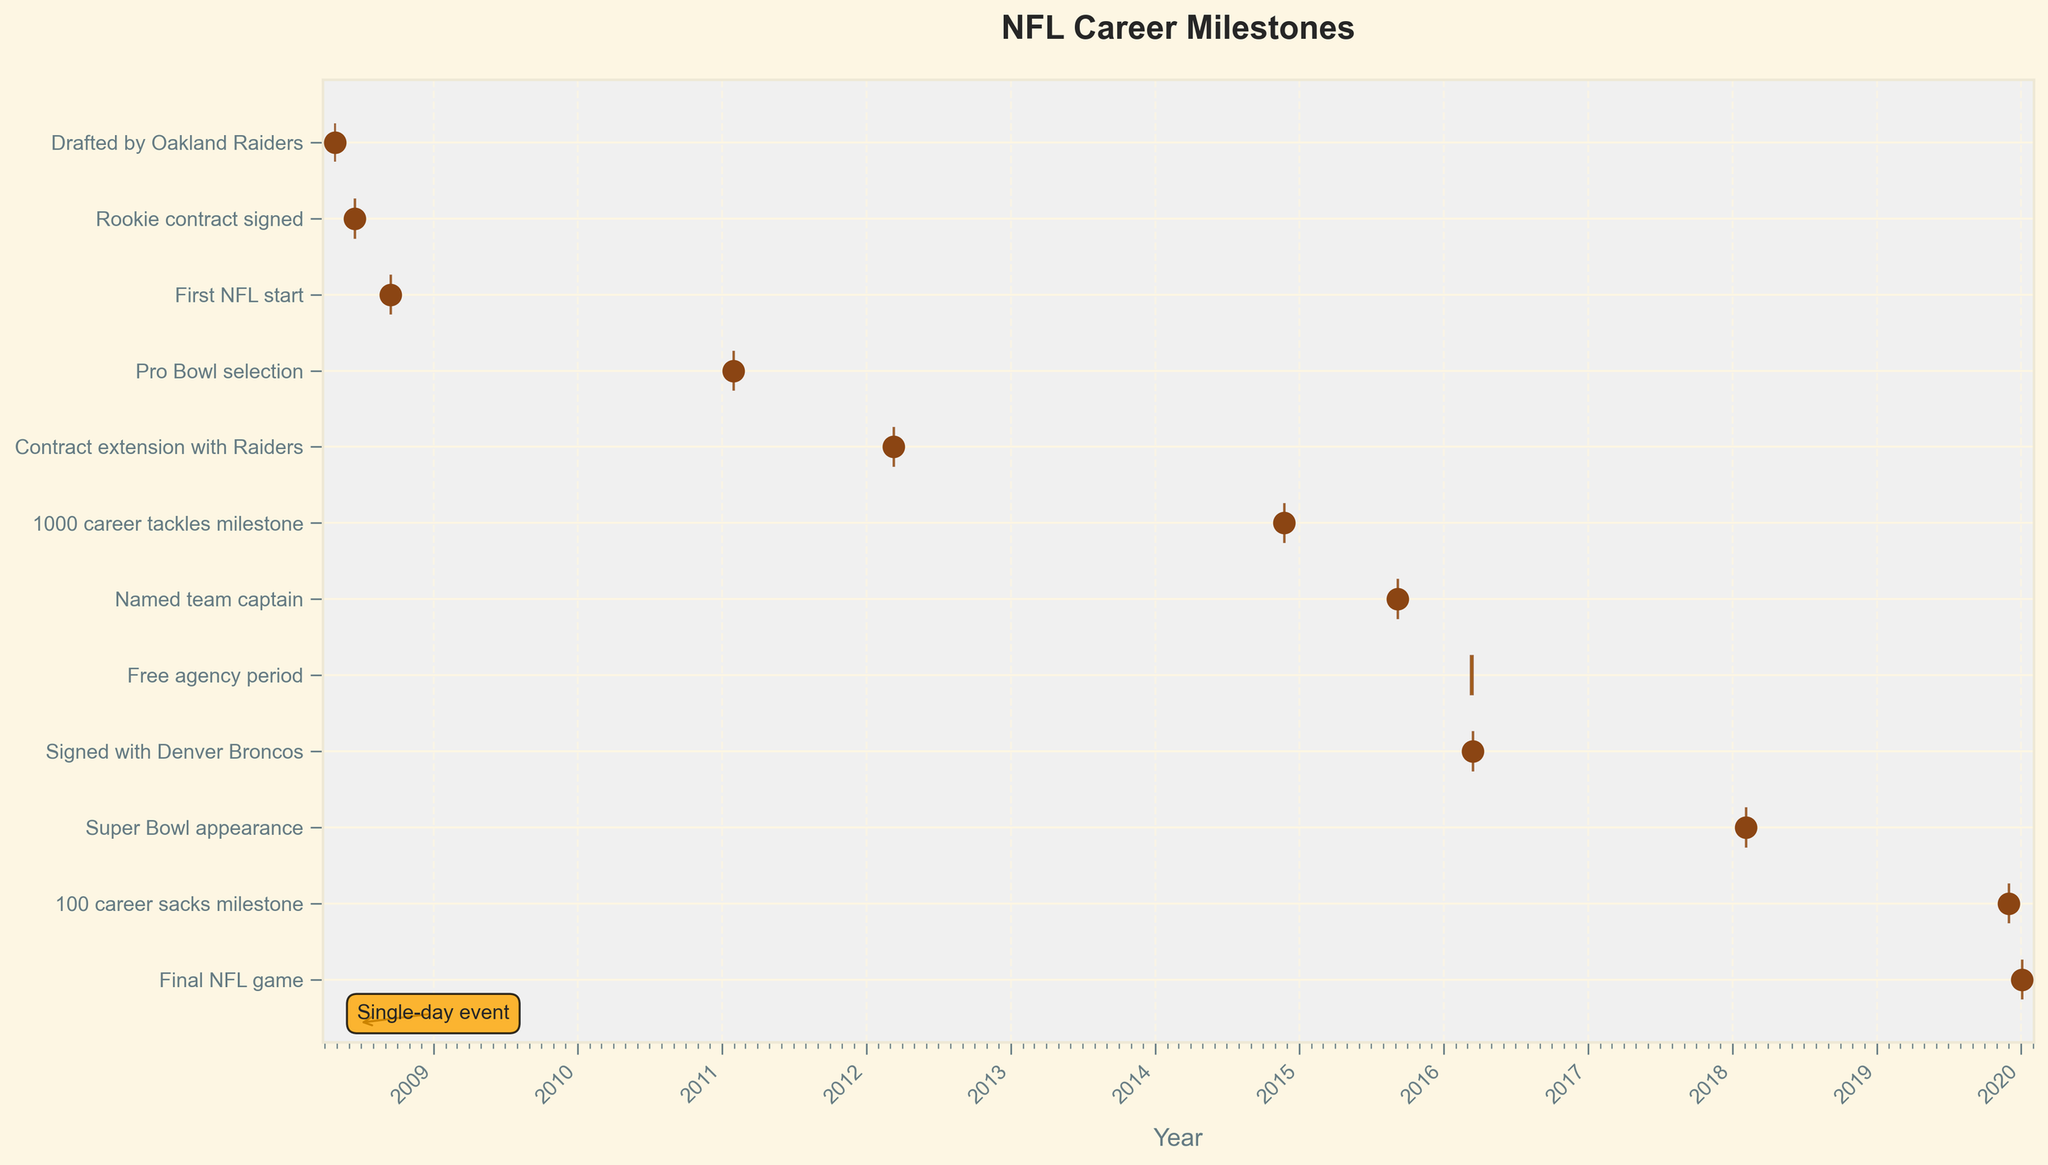What event marks the beginning of the player's professional NFL career? The event marking the beginning of the player's professional NFL career is "Drafted by Oakland Raiders". This can be seen at the earliest date on the Gantt Chart, which is April 26, 2008.
Answer: Drafted by Oakland Raiders How many days does the free agency period last? The "Free agency period" lasts from March 9, 2016, to March 14, 2016. By calculating the duration, (March 14 - March 9) including both start and end dates, we get a total of 6 days.
Answer: 6 days Which events are represented as single-day events with markers on the Gantt Chart? The events represented as single-day events with markers are: "Drafted by Oakland Raiders," "Rookie contract signed," "First NFL start," "Pro Bowl selection," "Contract extension with Raiders," "1000 career tackles milestone," "Named team captain," "Signed with Denver Broncos," "Super Bowl appearance," "100 career sacks milestone," and "Final NFL game." These all occur on a single day as shown with markers.
Answer: 11 events When did the player sign with the Denver Broncos? The player signed with the Denver Broncos on March 15, 2016, as seen on the Gantt Chart under the task "Signed with Denver Broncos."
Answer: March 15, 2016 Which event came first: Pro Bowl selection or the Contract extension with Raiders? The Pro Bowl selection occurred on January 30, 2011, which can be observed before the Contract extension with the Raiders that happened on March 10, 2012, in the sequential order on the Gantt Chart.
Answer: Pro Bowl selection How long after being drafted did the player reach 1000 career tackles milestone? The player was drafted on April 26, 2008, and reached the 1000 career tackles milestone on November 23, 2014. To find the duration between these dates: 2014-04-26 to 2014-11-23 gives 6 years and roughly 7 months.
Answer: 6 years and 7 months Compare the time intervals between the Contract extension with the Raiders and the Free agency period. Which one lasted longer? The Contract extension with the Raiders was a single-day event on March 10, 2012. The Free agency period lasted from March 9, 2016, to March 14, 2016, totaling 6 days. Comparing these intervals shows the Free agency period lasted longer.
Answer: Free agency period Which milestone occurred in 2018 as per the Gantt Chart? The milestone that occurred in 2018 is the "Super Bowl appearance," which is marked on the chart on February 4, 2018.
Answer: Super Bowl appearance What is the last event recorded in the Gantt Chart for the player's career? The last event recorded in the Gantt Chart is the "Final NFL game," which took place on January 3, 2020, marking the end of the player's NFL career.
Answer: Final NFL game 